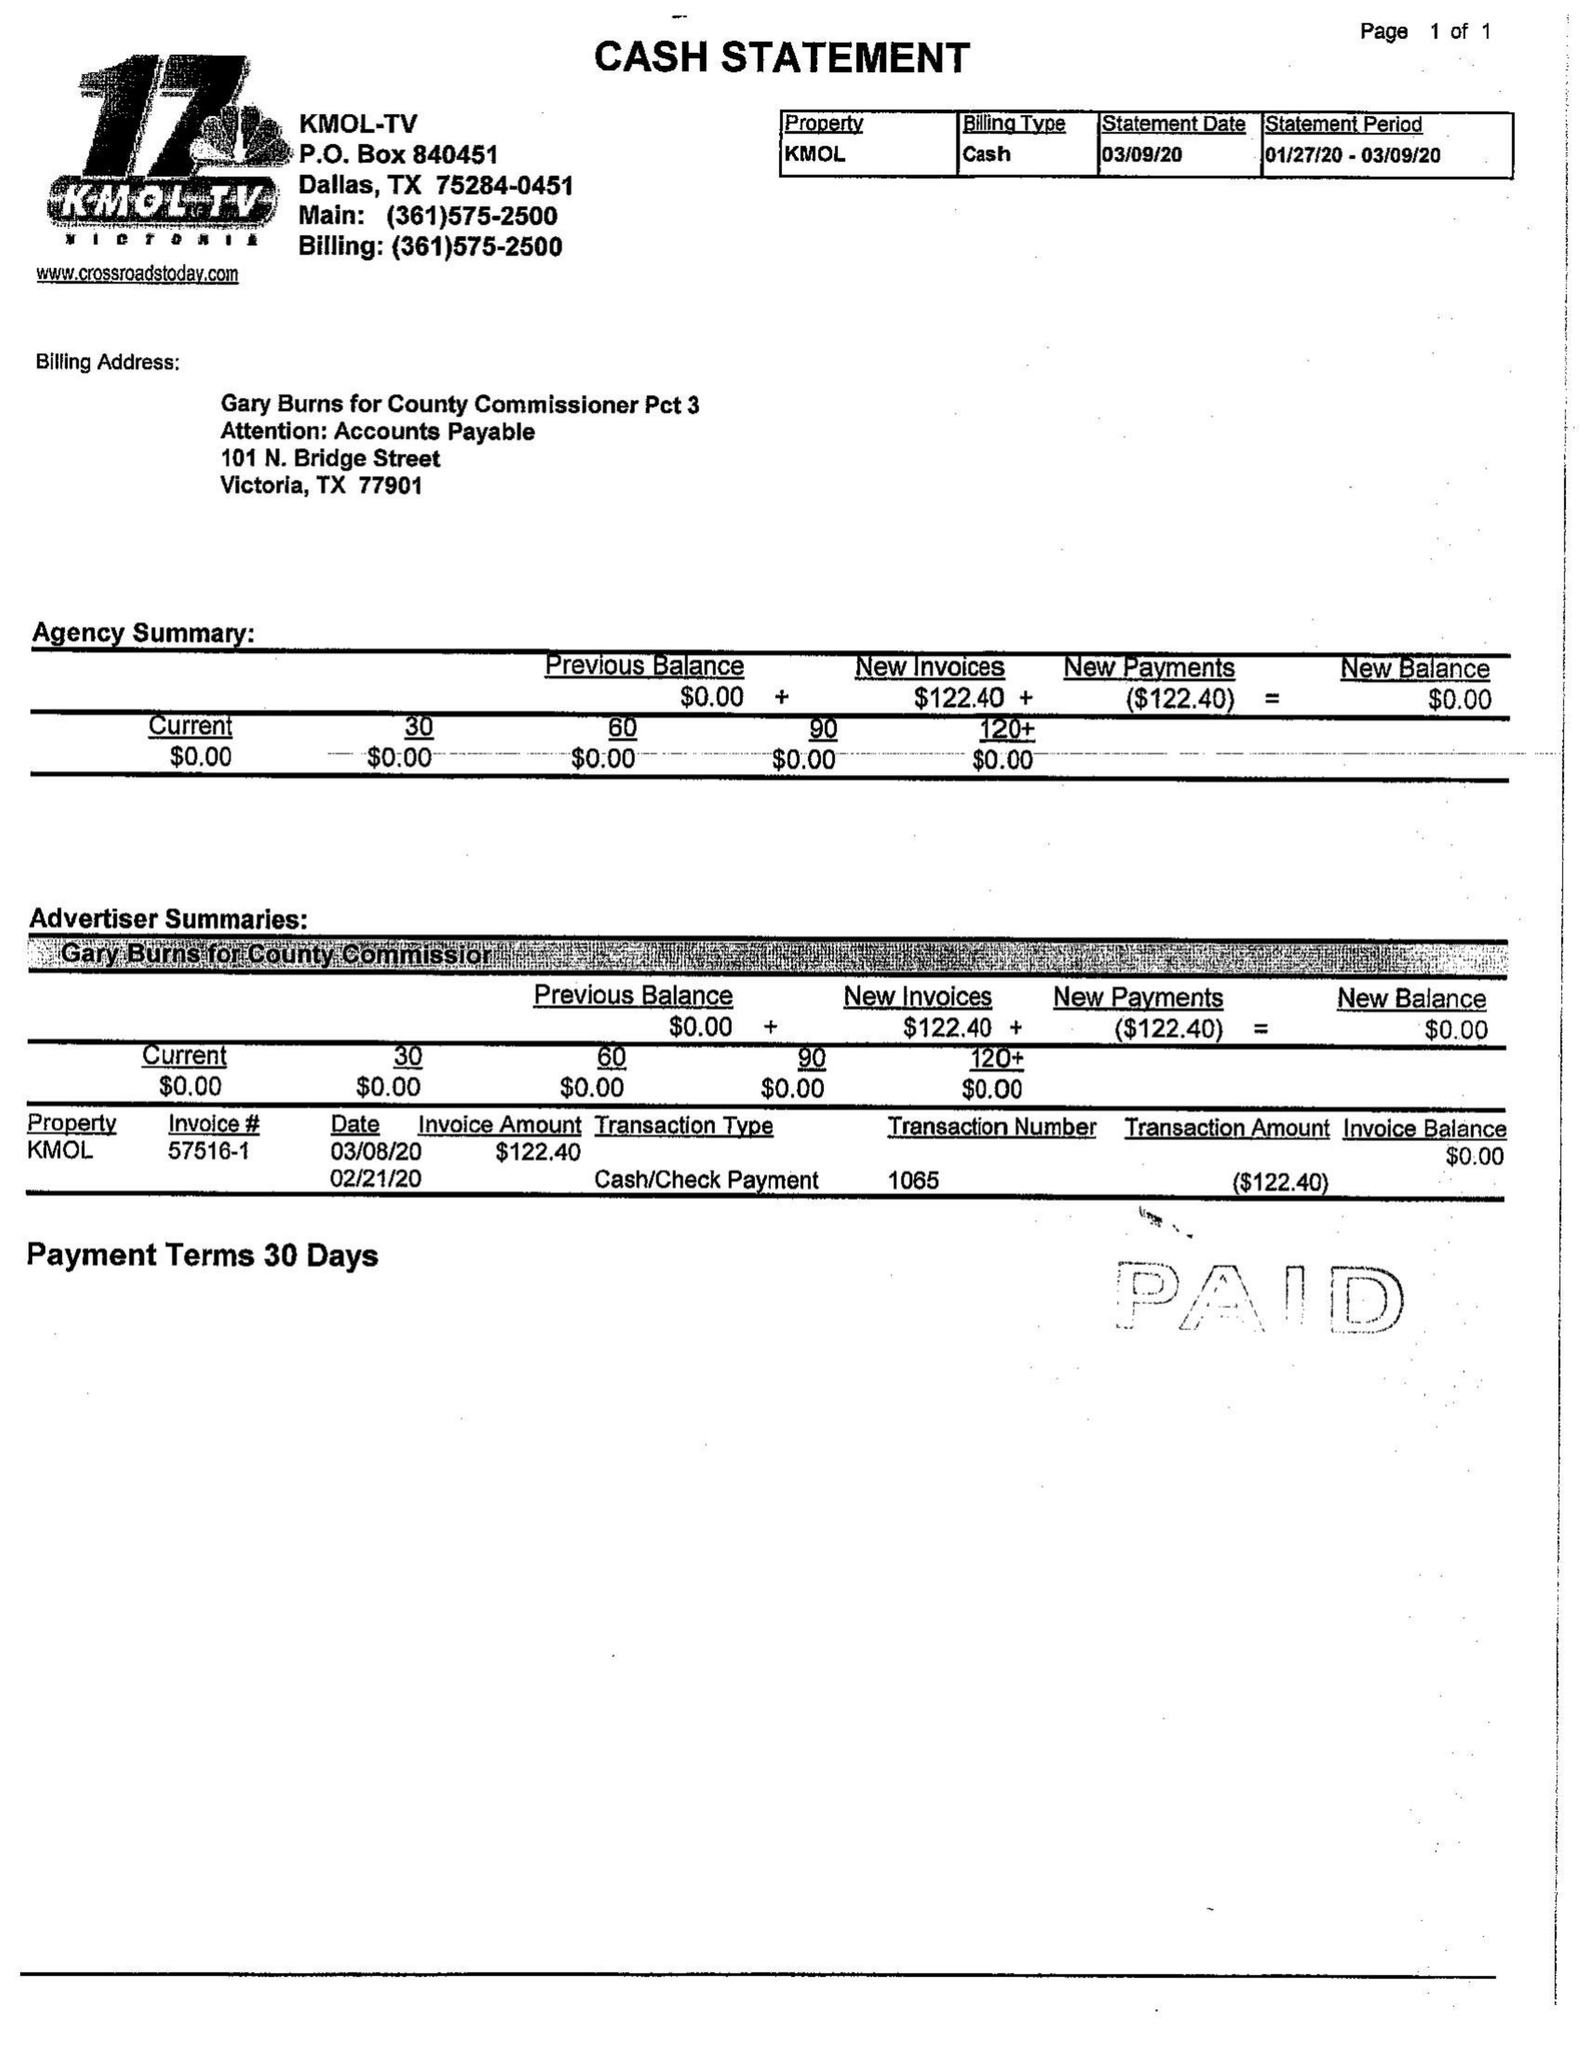What is the value for the flight_from?
Answer the question using a single word or phrase. 02/24/20 